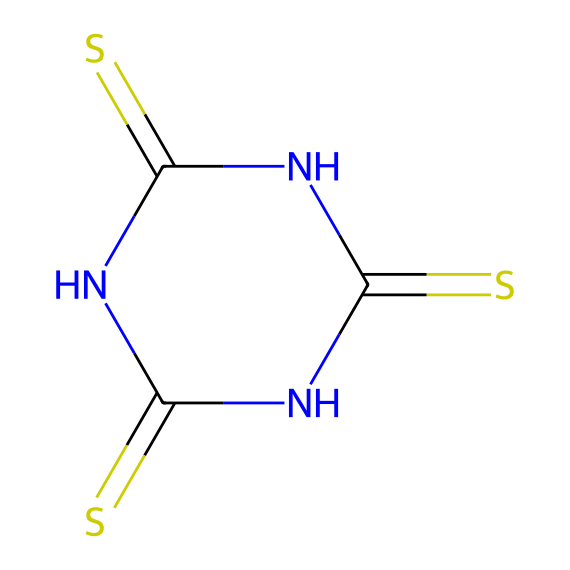What is the total number of sulfur atoms in this compound? The SMILES representation shows "S" symbols, indicating sulfur atoms. Counting them yields two sulfur atoms in the structure.
Answer: two How many nitrogen atoms are present in this chemical structure? In the SMILES, there are "N" symbols that indicate nitrogen atoms. There are three nitrogen atoms in the cyclic structure represented.
Answer: three What type of bonding would be primarily responsible for the durability of this compound? The multiple sulfur-containing groups suggest the presence of strong covalent bonds formed between sulfur atoms and surrounding elements, contributing to the adhesiveness and durability.
Answer: covalent Does this compound contain any double bonds? The presence of "C(=S)" indicates double bonds between carbon and sulfur atoms. Furthermore, these double bonds play a critical role in cross-linking, enhancing strength.
Answer: yes What functional groups are identified in this chemical? The presence of thioamide groups (R-NH-C(=S)-NH) is noted from the nitrogen and sulfur configuration, which plays a role in the adhesive properties of the material.
Answer: thioamide How might the cyclic structure influence the adhesive properties of this compound? The cyclic structure creates a stable framework enabling effective cross-linking, which enhances the overall mechanical properties of the adhesive, making it stronger.
Answer: stability What is a potential application of this organosulfur compound in sporting goods? This compound may be utilized in adhesives and sealants for bonding materials together, particularly in high-stress scenarios common in sporting equipment.
Answer: adhesives 